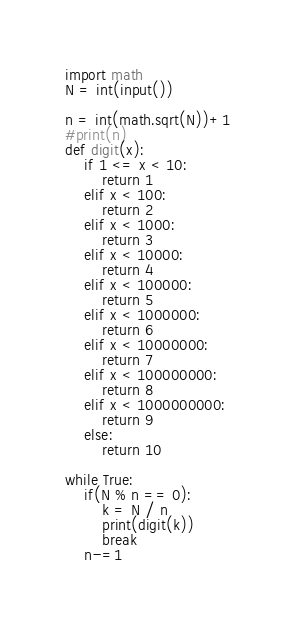<code> <loc_0><loc_0><loc_500><loc_500><_Python_>import math
N = int(input())

n = int(math.sqrt(N))+1
#print(n)
def digit(x):
    if 1 <= x < 10:
        return 1
    elif x < 100:
        return 2
    elif x < 1000:
        return 3
    elif x < 10000:
        return 4
    elif x < 100000:
        return 5
    elif x < 1000000:
        return 6
    elif x < 10000000:
        return 7
    elif x < 100000000:
        return 8
    elif x < 1000000000:
        return 9
    else:
        return 10

while True:
    if(N % n == 0):
        k = N / n
        print(digit(k))
        break
    n-=1
</code> 